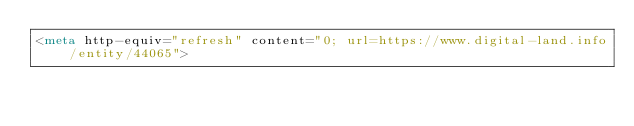<code> <loc_0><loc_0><loc_500><loc_500><_HTML_><meta http-equiv="refresh" content="0; url=https://www.digital-land.info/entity/44065"></code> 